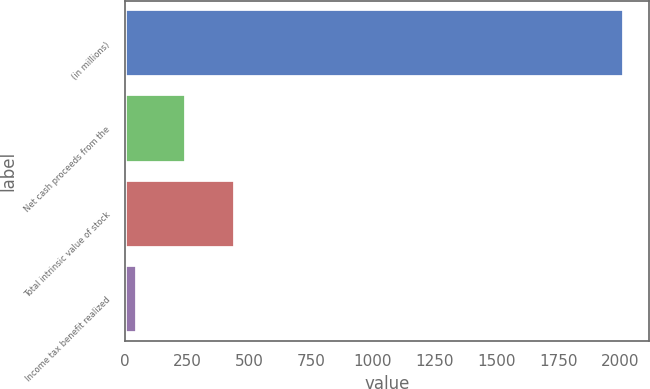Convert chart to OTSL. <chart><loc_0><loc_0><loc_500><loc_500><bar_chart><fcel>(in millions)<fcel>Net cash proceeds from the<fcel>Total intrinsic value of stock<fcel>Income tax benefit realized<nl><fcel>2015<fcel>245.6<fcel>442.2<fcel>49<nl></chart> 